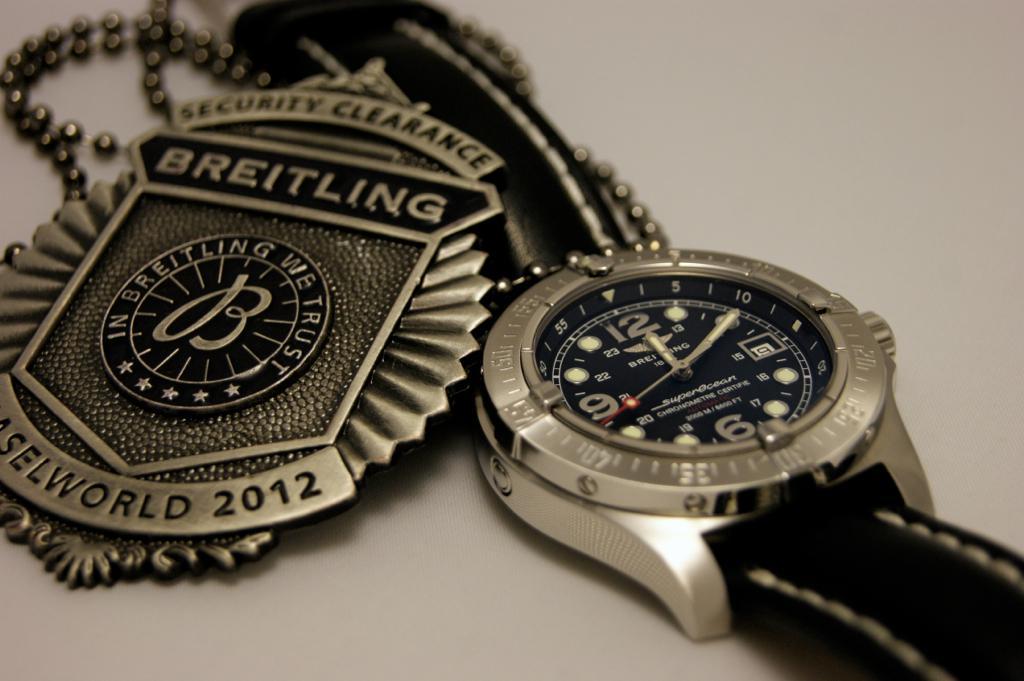What time is on the watch?
Keep it short and to the point. 12:10. What company is the medalion from?
Offer a terse response. Breitling. 